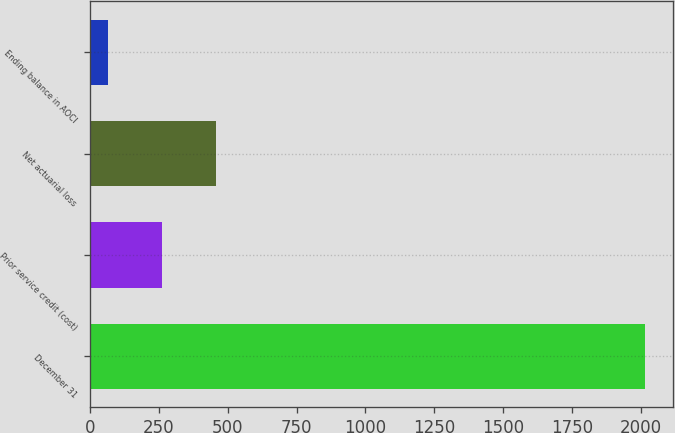Convert chart. <chart><loc_0><loc_0><loc_500><loc_500><bar_chart><fcel>December 31<fcel>Prior service credit (cost)<fcel>Net actuarial loss<fcel>Ending balance in AOCI<nl><fcel>2014<fcel>261.7<fcel>456.4<fcel>67<nl></chart> 